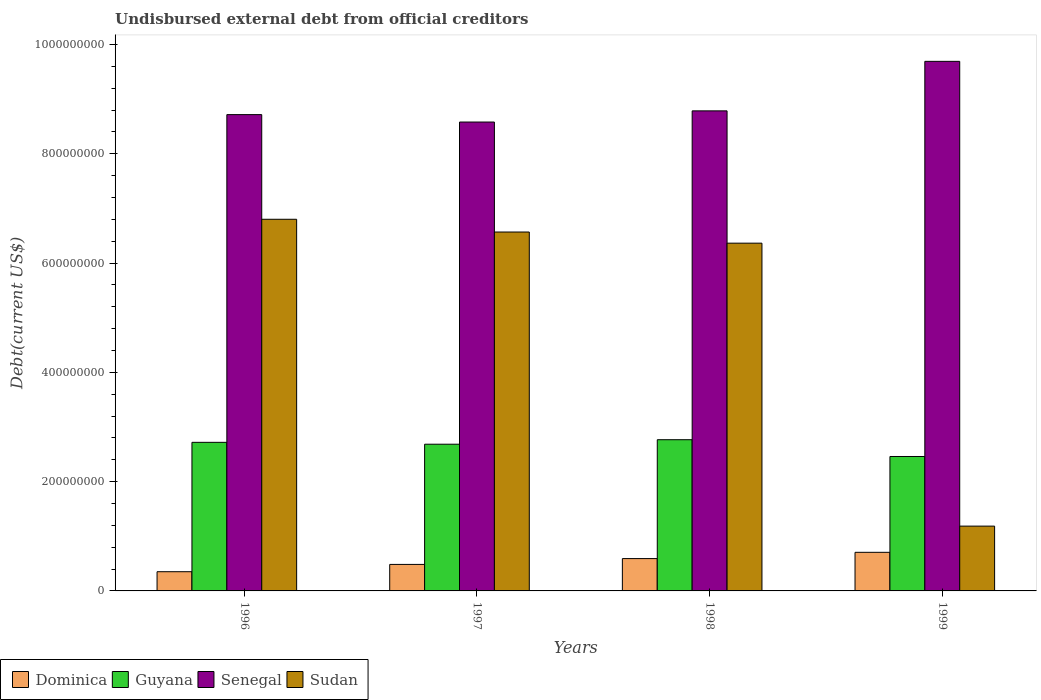How many different coloured bars are there?
Your answer should be very brief. 4. Are the number of bars on each tick of the X-axis equal?
Ensure brevity in your answer.  Yes. How many bars are there on the 3rd tick from the left?
Ensure brevity in your answer.  4. What is the total debt in Dominica in 1997?
Make the answer very short. 4.85e+07. Across all years, what is the maximum total debt in Senegal?
Offer a terse response. 9.69e+08. Across all years, what is the minimum total debt in Guyana?
Give a very brief answer. 2.46e+08. What is the total total debt in Sudan in the graph?
Your response must be concise. 2.09e+09. What is the difference between the total debt in Senegal in 1998 and that in 1999?
Give a very brief answer. -9.06e+07. What is the difference between the total debt in Senegal in 1998 and the total debt in Dominica in 1999?
Provide a succinct answer. 8.08e+08. What is the average total debt in Dominica per year?
Ensure brevity in your answer.  5.34e+07. In the year 1997, what is the difference between the total debt in Sudan and total debt in Guyana?
Keep it short and to the point. 3.88e+08. In how many years, is the total debt in Sudan greater than 320000000 US$?
Give a very brief answer. 3. What is the ratio of the total debt in Guyana in 1997 to that in 1998?
Your answer should be very brief. 0.97. Is the difference between the total debt in Sudan in 1997 and 1998 greater than the difference between the total debt in Guyana in 1997 and 1998?
Give a very brief answer. Yes. What is the difference between the highest and the second highest total debt in Guyana?
Make the answer very short. 4.81e+06. What is the difference between the highest and the lowest total debt in Guyana?
Your answer should be very brief. 3.07e+07. In how many years, is the total debt in Guyana greater than the average total debt in Guyana taken over all years?
Your response must be concise. 3. Is the sum of the total debt in Senegal in 1996 and 1999 greater than the maximum total debt in Guyana across all years?
Make the answer very short. Yes. What does the 1st bar from the left in 1996 represents?
Provide a succinct answer. Dominica. What does the 4th bar from the right in 1997 represents?
Make the answer very short. Dominica. Are all the bars in the graph horizontal?
Your response must be concise. No. How many years are there in the graph?
Provide a short and direct response. 4. Are the values on the major ticks of Y-axis written in scientific E-notation?
Offer a very short reply. No. Does the graph contain any zero values?
Give a very brief answer. No. Where does the legend appear in the graph?
Offer a very short reply. Bottom left. How are the legend labels stacked?
Give a very brief answer. Horizontal. What is the title of the graph?
Your response must be concise. Undisbursed external debt from official creditors. What is the label or title of the Y-axis?
Provide a short and direct response. Debt(current US$). What is the Debt(current US$) of Dominica in 1996?
Your response must be concise. 3.52e+07. What is the Debt(current US$) in Guyana in 1996?
Give a very brief answer. 2.72e+08. What is the Debt(current US$) of Senegal in 1996?
Keep it short and to the point. 8.72e+08. What is the Debt(current US$) of Sudan in 1996?
Provide a short and direct response. 6.80e+08. What is the Debt(current US$) of Dominica in 1997?
Provide a short and direct response. 4.85e+07. What is the Debt(current US$) in Guyana in 1997?
Make the answer very short. 2.68e+08. What is the Debt(current US$) of Senegal in 1997?
Provide a short and direct response. 8.58e+08. What is the Debt(current US$) of Sudan in 1997?
Your answer should be compact. 6.57e+08. What is the Debt(current US$) in Dominica in 1998?
Offer a very short reply. 5.92e+07. What is the Debt(current US$) in Guyana in 1998?
Provide a short and direct response. 2.77e+08. What is the Debt(current US$) of Senegal in 1998?
Make the answer very short. 8.78e+08. What is the Debt(current US$) in Sudan in 1998?
Ensure brevity in your answer.  6.36e+08. What is the Debt(current US$) in Dominica in 1999?
Give a very brief answer. 7.06e+07. What is the Debt(current US$) of Guyana in 1999?
Offer a terse response. 2.46e+08. What is the Debt(current US$) of Senegal in 1999?
Your answer should be very brief. 9.69e+08. What is the Debt(current US$) of Sudan in 1999?
Your answer should be compact. 1.19e+08. Across all years, what is the maximum Debt(current US$) in Dominica?
Offer a terse response. 7.06e+07. Across all years, what is the maximum Debt(current US$) in Guyana?
Ensure brevity in your answer.  2.77e+08. Across all years, what is the maximum Debt(current US$) of Senegal?
Your answer should be very brief. 9.69e+08. Across all years, what is the maximum Debt(current US$) in Sudan?
Offer a very short reply. 6.80e+08. Across all years, what is the minimum Debt(current US$) in Dominica?
Your answer should be very brief. 3.52e+07. Across all years, what is the minimum Debt(current US$) of Guyana?
Your response must be concise. 2.46e+08. Across all years, what is the minimum Debt(current US$) in Senegal?
Make the answer very short. 8.58e+08. Across all years, what is the minimum Debt(current US$) in Sudan?
Make the answer very short. 1.19e+08. What is the total Debt(current US$) of Dominica in the graph?
Offer a very short reply. 2.13e+08. What is the total Debt(current US$) of Guyana in the graph?
Your answer should be very brief. 1.06e+09. What is the total Debt(current US$) in Senegal in the graph?
Provide a succinct answer. 3.58e+09. What is the total Debt(current US$) of Sudan in the graph?
Provide a short and direct response. 2.09e+09. What is the difference between the Debt(current US$) in Dominica in 1996 and that in 1997?
Keep it short and to the point. -1.34e+07. What is the difference between the Debt(current US$) of Guyana in 1996 and that in 1997?
Your answer should be compact. 3.42e+06. What is the difference between the Debt(current US$) in Senegal in 1996 and that in 1997?
Offer a terse response. 1.36e+07. What is the difference between the Debt(current US$) of Sudan in 1996 and that in 1997?
Give a very brief answer. 2.33e+07. What is the difference between the Debt(current US$) in Dominica in 1996 and that in 1998?
Your answer should be compact. -2.40e+07. What is the difference between the Debt(current US$) of Guyana in 1996 and that in 1998?
Provide a short and direct response. -4.81e+06. What is the difference between the Debt(current US$) in Senegal in 1996 and that in 1998?
Your answer should be compact. -6.86e+06. What is the difference between the Debt(current US$) of Sudan in 1996 and that in 1998?
Provide a succinct answer. 4.37e+07. What is the difference between the Debt(current US$) in Dominica in 1996 and that in 1999?
Your answer should be very brief. -3.55e+07. What is the difference between the Debt(current US$) in Guyana in 1996 and that in 1999?
Offer a very short reply. 2.59e+07. What is the difference between the Debt(current US$) of Senegal in 1996 and that in 1999?
Offer a very short reply. -9.75e+07. What is the difference between the Debt(current US$) in Sudan in 1996 and that in 1999?
Ensure brevity in your answer.  5.62e+08. What is the difference between the Debt(current US$) of Dominica in 1997 and that in 1998?
Offer a terse response. -1.07e+07. What is the difference between the Debt(current US$) of Guyana in 1997 and that in 1998?
Make the answer very short. -8.23e+06. What is the difference between the Debt(current US$) in Senegal in 1997 and that in 1998?
Keep it short and to the point. -2.04e+07. What is the difference between the Debt(current US$) in Sudan in 1997 and that in 1998?
Offer a very short reply. 2.04e+07. What is the difference between the Debt(current US$) of Dominica in 1997 and that in 1999?
Keep it short and to the point. -2.21e+07. What is the difference between the Debt(current US$) in Guyana in 1997 and that in 1999?
Provide a succinct answer. 2.25e+07. What is the difference between the Debt(current US$) of Senegal in 1997 and that in 1999?
Give a very brief answer. -1.11e+08. What is the difference between the Debt(current US$) in Sudan in 1997 and that in 1999?
Offer a very short reply. 5.38e+08. What is the difference between the Debt(current US$) of Dominica in 1998 and that in 1999?
Your answer should be very brief. -1.15e+07. What is the difference between the Debt(current US$) in Guyana in 1998 and that in 1999?
Make the answer very short. 3.07e+07. What is the difference between the Debt(current US$) of Senegal in 1998 and that in 1999?
Offer a very short reply. -9.06e+07. What is the difference between the Debt(current US$) in Sudan in 1998 and that in 1999?
Offer a very short reply. 5.18e+08. What is the difference between the Debt(current US$) in Dominica in 1996 and the Debt(current US$) in Guyana in 1997?
Keep it short and to the point. -2.33e+08. What is the difference between the Debt(current US$) in Dominica in 1996 and the Debt(current US$) in Senegal in 1997?
Your answer should be compact. -8.23e+08. What is the difference between the Debt(current US$) in Dominica in 1996 and the Debt(current US$) in Sudan in 1997?
Your answer should be compact. -6.22e+08. What is the difference between the Debt(current US$) in Guyana in 1996 and the Debt(current US$) in Senegal in 1997?
Provide a succinct answer. -5.86e+08. What is the difference between the Debt(current US$) in Guyana in 1996 and the Debt(current US$) in Sudan in 1997?
Provide a succinct answer. -3.85e+08. What is the difference between the Debt(current US$) in Senegal in 1996 and the Debt(current US$) in Sudan in 1997?
Your response must be concise. 2.15e+08. What is the difference between the Debt(current US$) in Dominica in 1996 and the Debt(current US$) in Guyana in 1998?
Offer a terse response. -2.42e+08. What is the difference between the Debt(current US$) of Dominica in 1996 and the Debt(current US$) of Senegal in 1998?
Provide a short and direct response. -8.43e+08. What is the difference between the Debt(current US$) of Dominica in 1996 and the Debt(current US$) of Sudan in 1998?
Your answer should be very brief. -6.01e+08. What is the difference between the Debt(current US$) of Guyana in 1996 and the Debt(current US$) of Senegal in 1998?
Make the answer very short. -6.07e+08. What is the difference between the Debt(current US$) in Guyana in 1996 and the Debt(current US$) in Sudan in 1998?
Provide a short and direct response. -3.64e+08. What is the difference between the Debt(current US$) of Senegal in 1996 and the Debt(current US$) of Sudan in 1998?
Ensure brevity in your answer.  2.35e+08. What is the difference between the Debt(current US$) in Dominica in 1996 and the Debt(current US$) in Guyana in 1999?
Give a very brief answer. -2.11e+08. What is the difference between the Debt(current US$) in Dominica in 1996 and the Debt(current US$) in Senegal in 1999?
Your response must be concise. -9.34e+08. What is the difference between the Debt(current US$) in Dominica in 1996 and the Debt(current US$) in Sudan in 1999?
Offer a very short reply. -8.34e+07. What is the difference between the Debt(current US$) of Guyana in 1996 and the Debt(current US$) of Senegal in 1999?
Your answer should be very brief. -6.97e+08. What is the difference between the Debt(current US$) of Guyana in 1996 and the Debt(current US$) of Sudan in 1999?
Your answer should be very brief. 1.53e+08. What is the difference between the Debt(current US$) of Senegal in 1996 and the Debt(current US$) of Sudan in 1999?
Provide a short and direct response. 7.53e+08. What is the difference between the Debt(current US$) in Dominica in 1997 and the Debt(current US$) in Guyana in 1998?
Your answer should be compact. -2.28e+08. What is the difference between the Debt(current US$) of Dominica in 1997 and the Debt(current US$) of Senegal in 1998?
Give a very brief answer. -8.30e+08. What is the difference between the Debt(current US$) of Dominica in 1997 and the Debt(current US$) of Sudan in 1998?
Your response must be concise. -5.88e+08. What is the difference between the Debt(current US$) of Guyana in 1997 and the Debt(current US$) of Senegal in 1998?
Your answer should be compact. -6.10e+08. What is the difference between the Debt(current US$) in Guyana in 1997 and the Debt(current US$) in Sudan in 1998?
Your answer should be very brief. -3.68e+08. What is the difference between the Debt(current US$) of Senegal in 1997 and the Debt(current US$) of Sudan in 1998?
Offer a very short reply. 2.22e+08. What is the difference between the Debt(current US$) in Dominica in 1997 and the Debt(current US$) in Guyana in 1999?
Give a very brief answer. -1.97e+08. What is the difference between the Debt(current US$) in Dominica in 1997 and the Debt(current US$) in Senegal in 1999?
Provide a short and direct response. -9.21e+08. What is the difference between the Debt(current US$) in Dominica in 1997 and the Debt(current US$) in Sudan in 1999?
Give a very brief answer. -7.01e+07. What is the difference between the Debt(current US$) of Guyana in 1997 and the Debt(current US$) of Senegal in 1999?
Keep it short and to the point. -7.01e+08. What is the difference between the Debt(current US$) in Guyana in 1997 and the Debt(current US$) in Sudan in 1999?
Keep it short and to the point. 1.50e+08. What is the difference between the Debt(current US$) of Senegal in 1997 and the Debt(current US$) of Sudan in 1999?
Keep it short and to the point. 7.39e+08. What is the difference between the Debt(current US$) of Dominica in 1998 and the Debt(current US$) of Guyana in 1999?
Give a very brief answer. -1.87e+08. What is the difference between the Debt(current US$) in Dominica in 1998 and the Debt(current US$) in Senegal in 1999?
Offer a very short reply. -9.10e+08. What is the difference between the Debt(current US$) in Dominica in 1998 and the Debt(current US$) in Sudan in 1999?
Your answer should be very brief. -5.94e+07. What is the difference between the Debt(current US$) of Guyana in 1998 and the Debt(current US$) of Senegal in 1999?
Your response must be concise. -6.92e+08. What is the difference between the Debt(current US$) of Guyana in 1998 and the Debt(current US$) of Sudan in 1999?
Your answer should be compact. 1.58e+08. What is the difference between the Debt(current US$) in Senegal in 1998 and the Debt(current US$) in Sudan in 1999?
Your response must be concise. 7.60e+08. What is the average Debt(current US$) of Dominica per year?
Provide a short and direct response. 5.34e+07. What is the average Debt(current US$) of Guyana per year?
Offer a terse response. 2.66e+08. What is the average Debt(current US$) in Senegal per year?
Offer a terse response. 8.94e+08. What is the average Debt(current US$) of Sudan per year?
Your response must be concise. 5.23e+08. In the year 1996, what is the difference between the Debt(current US$) in Dominica and Debt(current US$) in Guyana?
Provide a succinct answer. -2.37e+08. In the year 1996, what is the difference between the Debt(current US$) of Dominica and Debt(current US$) of Senegal?
Your answer should be very brief. -8.36e+08. In the year 1996, what is the difference between the Debt(current US$) in Dominica and Debt(current US$) in Sudan?
Your answer should be compact. -6.45e+08. In the year 1996, what is the difference between the Debt(current US$) of Guyana and Debt(current US$) of Senegal?
Keep it short and to the point. -6.00e+08. In the year 1996, what is the difference between the Debt(current US$) of Guyana and Debt(current US$) of Sudan?
Offer a very short reply. -4.08e+08. In the year 1996, what is the difference between the Debt(current US$) of Senegal and Debt(current US$) of Sudan?
Make the answer very short. 1.91e+08. In the year 1997, what is the difference between the Debt(current US$) of Dominica and Debt(current US$) of Guyana?
Ensure brevity in your answer.  -2.20e+08. In the year 1997, what is the difference between the Debt(current US$) of Dominica and Debt(current US$) of Senegal?
Ensure brevity in your answer.  -8.09e+08. In the year 1997, what is the difference between the Debt(current US$) in Dominica and Debt(current US$) in Sudan?
Your answer should be very brief. -6.08e+08. In the year 1997, what is the difference between the Debt(current US$) in Guyana and Debt(current US$) in Senegal?
Offer a terse response. -5.90e+08. In the year 1997, what is the difference between the Debt(current US$) in Guyana and Debt(current US$) in Sudan?
Give a very brief answer. -3.88e+08. In the year 1997, what is the difference between the Debt(current US$) in Senegal and Debt(current US$) in Sudan?
Provide a succinct answer. 2.01e+08. In the year 1998, what is the difference between the Debt(current US$) of Dominica and Debt(current US$) of Guyana?
Your response must be concise. -2.18e+08. In the year 1998, what is the difference between the Debt(current US$) in Dominica and Debt(current US$) in Senegal?
Provide a short and direct response. -8.19e+08. In the year 1998, what is the difference between the Debt(current US$) in Dominica and Debt(current US$) in Sudan?
Offer a very short reply. -5.77e+08. In the year 1998, what is the difference between the Debt(current US$) of Guyana and Debt(current US$) of Senegal?
Provide a succinct answer. -6.02e+08. In the year 1998, what is the difference between the Debt(current US$) of Guyana and Debt(current US$) of Sudan?
Offer a terse response. -3.60e+08. In the year 1998, what is the difference between the Debt(current US$) of Senegal and Debt(current US$) of Sudan?
Provide a succinct answer. 2.42e+08. In the year 1999, what is the difference between the Debt(current US$) in Dominica and Debt(current US$) in Guyana?
Offer a very short reply. -1.75e+08. In the year 1999, what is the difference between the Debt(current US$) of Dominica and Debt(current US$) of Senegal?
Your answer should be very brief. -8.98e+08. In the year 1999, what is the difference between the Debt(current US$) of Dominica and Debt(current US$) of Sudan?
Offer a terse response. -4.79e+07. In the year 1999, what is the difference between the Debt(current US$) of Guyana and Debt(current US$) of Senegal?
Offer a very short reply. -7.23e+08. In the year 1999, what is the difference between the Debt(current US$) of Guyana and Debt(current US$) of Sudan?
Provide a succinct answer. 1.27e+08. In the year 1999, what is the difference between the Debt(current US$) in Senegal and Debt(current US$) in Sudan?
Your answer should be very brief. 8.50e+08. What is the ratio of the Debt(current US$) of Dominica in 1996 to that in 1997?
Make the answer very short. 0.72. What is the ratio of the Debt(current US$) of Guyana in 1996 to that in 1997?
Offer a terse response. 1.01. What is the ratio of the Debt(current US$) of Senegal in 1996 to that in 1997?
Give a very brief answer. 1.02. What is the ratio of the Debt(current US$) in Sudan in 1996 to that in 1997?
Offer a very short reply. 1.04. What is the ratio of the Debt(current US$) in Dominica in 1996 to that in 1998?
Offer a very short reply. 0.59. What is the ratio of the Debt(current US$) in Guyana in 1996 to that in 1998?
Give a very brief answer. 0.98. What is the ratio of the Debt(current US$) in Senegal in 1996 to that in 1998?
Give a very brief answer. 0.99. What is the ratio of the Debt(current US$) in Sudan in 1996 to that in 1998?
Your answer should be very brief. 1.07. What is the ratio of the Debt(current US$) in Dominica in 1996 to that in 1999?
Provide a succinct answer. 0.5. What is the ratio of the Debt(current US$) in Guyana in 1996 to that in 1999?
Ensure brevity in your answer.  1.11. What is the ratio of the Debt(current US$) in Senegal in 1996 to that in 1999?
Ensure brevity in your answer.  0.9. What is the ratio of the Debt(current US$) in Sudan in 1996 to that in 1999?
Your answer should be compact. 5.74. What is the ratio of the Debt(current US$) in Dominica in 1997 to that in 1998?
Provide a short and direct response. 0.82. What is the ratio of the Debt(current US$) in Guyana in 1997 to that in 1998?
Keep it short and to the point. 0.97. What is the ratio of the Debt(current US$) of Senegal in 1997 to that in 1998?
Your response must be concise. 0.98. What is the ratio of the Debt(current US$) of Sudan in 1997 to that in 1998?
Give a very brief answer. 1.03. What is the ratio of the Debt(current US$) of Dominica in 1997 to that in 1999?
Your answer should be very brief. 0.69. What is the ratio of the Debt(current US$) in Guyana in 1997 to that in 1999?
Offer a very short reply. 1.09. What is the ratio of the Debt(current US$) in Senegal in 1997 to that in 1999?
Give a very brief answer. 0.89. What is the ratio of the Debt(current US$) of Sudan in 1997 to that in 1999?
Offer a terse response. 5.54. What is the ratio of the Debt(current US$) of Dominica in 1998 to that in 1999?
Your answer should be very brief. 0.84. What is the ratio of the Debt(current US$) in Guyana in 1998 to that in 1999?
Offer a very short reply. 1.12. What is the ratio of the Debt(current US$) in Senegal in 1998 to that in 1999?
Offer a very short reply. 0.91. What is the ratio of the Debt(current US$) of Sudan in 1998 to that in 1999?
Your response must be concise. 5.37. What is the difference between the highest and the second highest Debt(current US$) of Dominica?
Your answer should be very brief. 1.15e+07. What is the difference between the highest and the second highest Debt(current US$) of Guyana?
Ensure brevity in your answer.  4.81e+06. What is the difference between the highest and the second highest Debt(current US$) of Senegal?
Your response must be concise. 9.06e+07. What is the difference between the highest and the second highest Debt(current US$) of Sudan?
Provide a short and direct response. 2.33e+07. What is the difference between the highest and the lowest Debt(current US$) in Dominica?
Your response must be concise. 3.55e+07. What is the difference between the highest and the lowest Debt(current US$) of Guyana?
Make the answer very short. 3.07e+07. What is the difference between the highest and the lowest Debt(current US$) of Senegal?
Your answer should be compact. 1.11e+08. What is the difference between the highest and the lowest Debt(current US$) of Sudan?
Your answer should be very brief. 5.62e+08. 